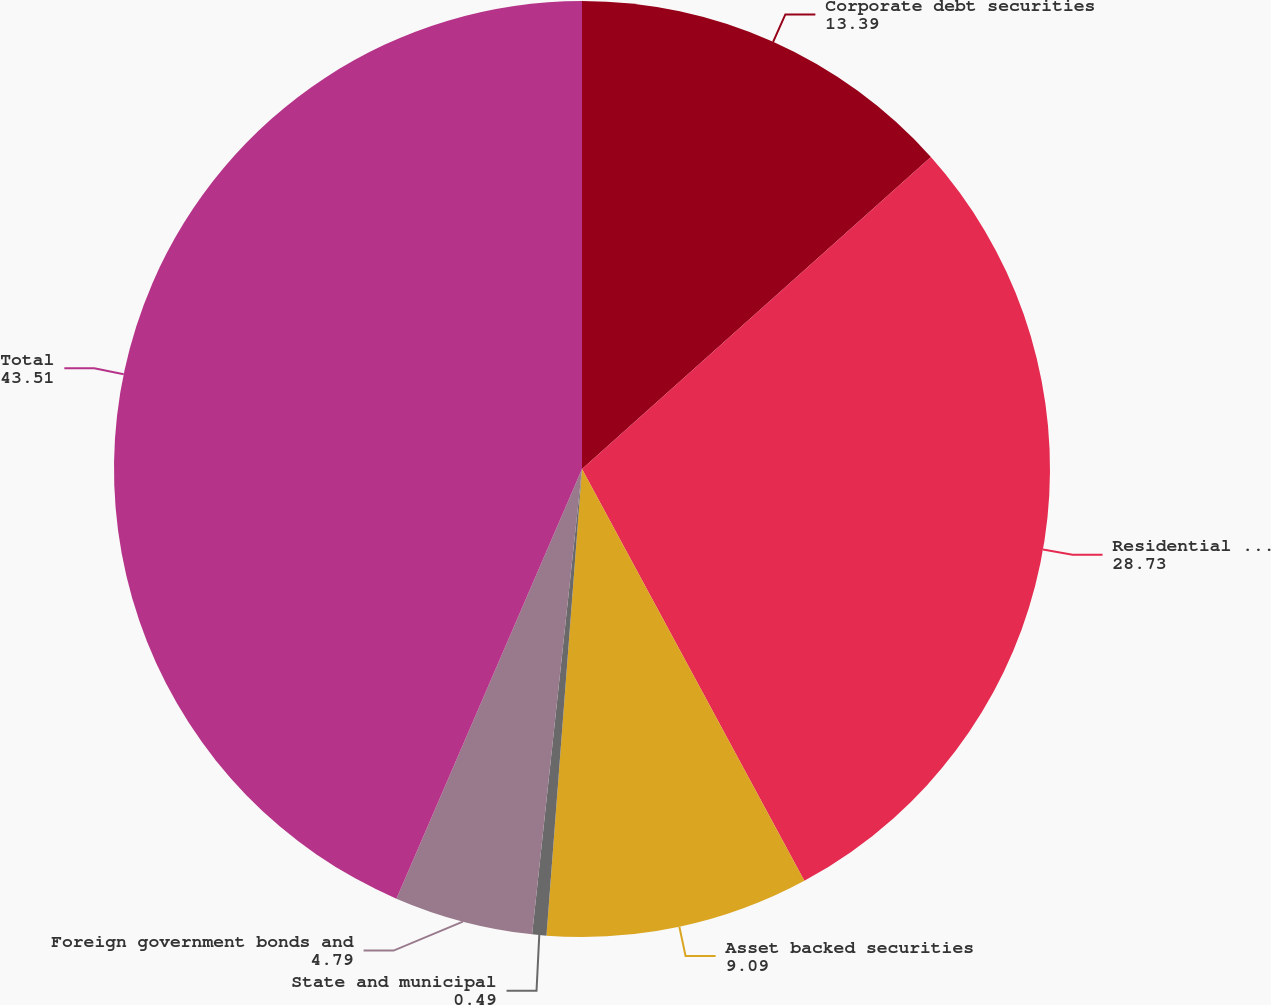<chart> <loc_0><loc_0><loc_500><loc_500><pie_chart><fcel>Corporate debt securities<fcel>Residential mortgage backed<fcel>Asset backed securities<fcel>State and municipal<fcel>Foreign government bonds and<fcel>Total<nl><fcel>13.39%<fcel>28.73%<fcel>9.09%<fcel>0.49%<fcel>4.79%<fcel>43.51%<nl></chart> 